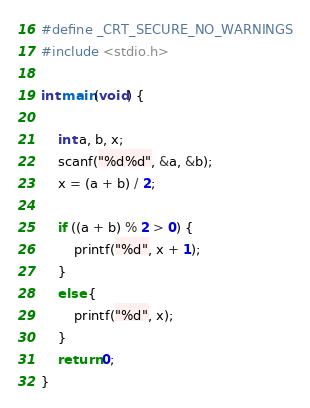<code> <loc_0><loc_0><loc_500><loc_500><_C_>#define _CRT_SECURE_NO_WARNINGS
#include <stdio.h>

int main(void) {

	int a, b, x;
	scanf("%d%d", &a, &b);
	x = (a + b) / 2;

	if ((a + b) % 2 > 0) {
		printf("%d", x + 1);
	}
	else {
		printf("%d", x);
	}
	return 0;
}</code> 